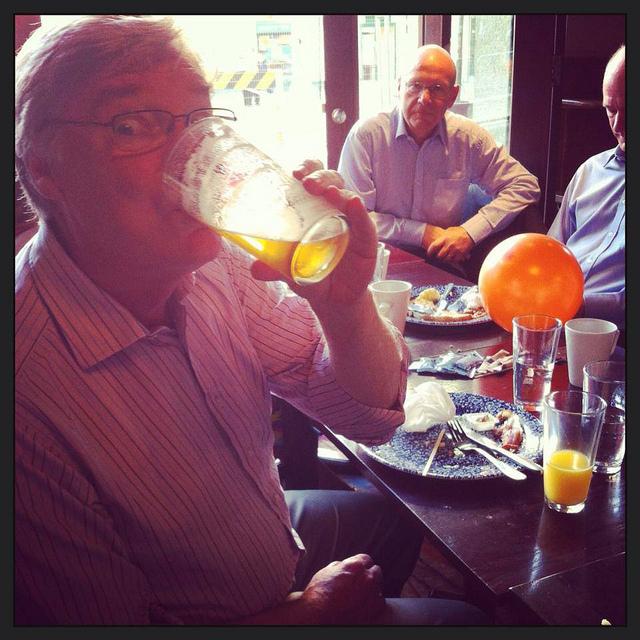Is there a balloon on the table?
Answer briefly. Yes. Have the men started eating?
Short answer required. Yes. Is this a birthday party?
Answer briefly. No. 